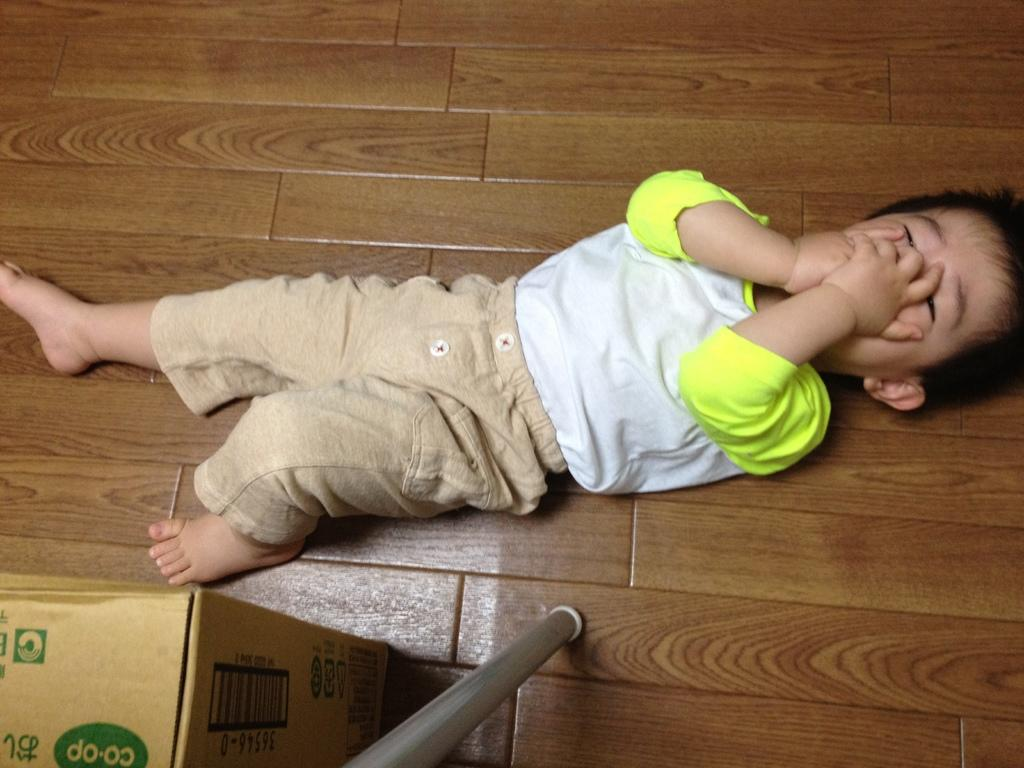What is the position of the kid in the image? The kid is lying on the floor in the image. What object can be seen at the bottom of the image? There is a carton box at the bottom of the image. What is the pole used for in the image? The pole is on the floor in the image, but its purpose is not specified. How many houses are visible in the image? There are no houses visible in the image. On which side of the kid is the pole located? The pole's position relative to the kid is not specified in the image. 